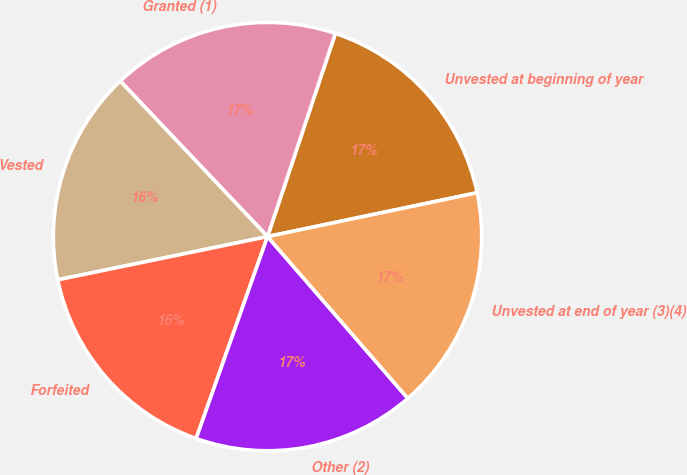Convert chart to OTSL. <chart><loc_0><loc_0><loc_500><loc_500><pie_chart><fcel>Unvested at beginning of year<fcel>Granted (1)<fcel>Vested<fcel>Forfeited<fcel>Other (2)<fcel>Unvested at end of year (3)(4)<nl><fcel>16.59%<fcel>17.2%<fcel>16.17%<fcel>16.36%<fcel>16.78%<fcel>16.91%<nl></chart> 